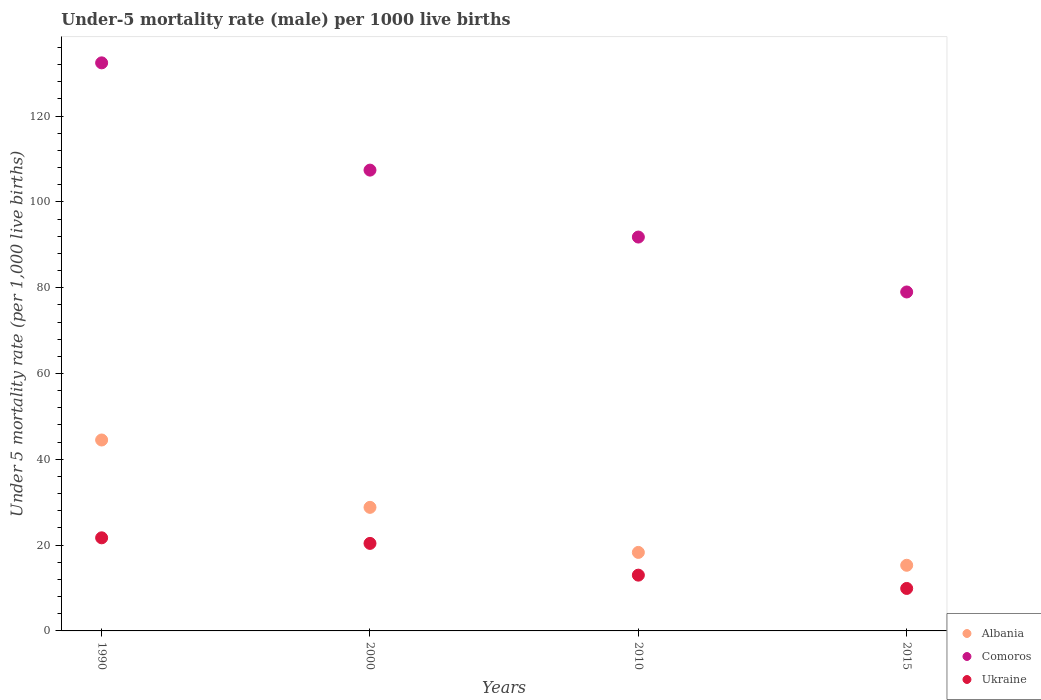What is the under-five mortality rate in Ukraine in 2015?
Make the answer very short. 9.9. Across all years, what is the maximum under-five mortality rate in Ukraine?
Your answer should be compact. 21.7. Across all years, what is the minimum under-five mortality rate in Comoros?
Keep it short and to the point. 79. In which year was the under-five mortality rate in Albania maximum?
Give a very brief answer. 1990. In which year was the under-five mortality rate in Albania minimum?
Offer a very short reply. 2015. What is the total under-five mortality rate in Comoros in the graph?
Make the answer very short. 410.6. What is the difference between the under-five mortality rate in Comoros in 1990 and that in 2000?
Ensure brevity in your answer.  25. What is the difference between the under-five mortality rate in Comoros in 2015 and the under-five mortality rate in Ukraine in 1990?
Give a very brief answer. 57.3. What is the average under-five mortality rate in Ukraine per year?
Your response must be concise. 16.25. In the year 2010, what is the difference between the under-five mortality rate in Ukraine and under-five mortality rate in Albania?
Ensure brevity in your answer.  -5.3. What is the ratio of the under-five mortality rate in Comoros in 2000 to that in 2010?
Give a very brief answer. 1.17. Is the under-five mortality rate in Ukraine in 2000 less than that in 2015?
Your answer should be very brief. No. Is the difference between the under-five mortality rate in Ukraine in 1990 and 2010 greater than the difference between the under-five mortality rate in Albania in 1990 and 2010?
Provide a succinct answer. No. What is the difference between the highest and the second highest under-five mortality rate in Albania?
Your answer should be very brief. 15.7. What is the difference between the highest and the lowest under-five mortality rate in Ukraine?
Your response must be concise. 11.8. In how many years, is the under-five mortality rate in Ukraine greater than the average under-five mortality rate in Ukraine taken over all years?
Your answer should be very brief. 2. Is it the case that in every year, the sum of the under-five mortality rate in Albania and under-five mortality rate in Ukraine  is greater than the under-five mortality rate in Comoros?
Offer a very short reply. No. Is the under-five mortality rate in Comoros strictly greater than the under-five mortality rate in Ukraine over the years?
Your response must be concise. Yes. Is the under-five mortality rate in Ukraine strictly less than the under-five mortality rate in Albania over the years?
Keep it short and to the point. Yes. What is the difference between two consecutive major ticks on the Y-axis?
Your answer should be compact. 20. Does the graph contain grids?
Keep it short and to the point. No. What is the title of the graph?
Provide a short and direct response. Under-5 mortality rate (male) per 1000 live births. What is the label or title of the X-axis?
Offer a very short reply. Years. What is the label or title of the Y-axis?
Give a very brief answer. Under 5 mortality rate (per 1,0 live births). What is the Under 5 mortality rate (per 1,000 live births) in Albania in 1990?
Your answer should be very brief. 44.5. What is the Under 5 mortality rate (per 1,000 live births) in Comoros in 1990?
Make the answer very short. 132.4. What is the Under 5 mortality rate (per 1,000 live births) of Ukraine in 1990?
Give a very brief answer. 21.7. What is the Under 5 mortality rate (per 1,000 live births) of Albania in 2000?
Offer a terse response. 28.8. What is the Under 5 mortality rate (per 1,000 live births) in Comoros in 2000?
Provide a short and direct response. 107.4. What is the Under 5 mortality rate (per 1,000 live births) of Ukraine in 2000?
Make the answer very short. 20.4. What is the Under 5 mortality rate (per 1,000 live births) in Comoros in 2010?
Your response must be concise. 91.8. What is the Under 5 mortality rate (per 1,000 live births) in Ukraine in 2010?
Your response must be concise. 13. What is the Under 5 mortality rate (per 1,000 live births) of Comoros in 2015?
Give a very brief answer. 79. Across all years, what is the maximum Under 5 mortality rate (per 1,000 live births) of Albania?
Ensure brevity in your answer.  44.5. Across all years, what is the maximum Under 5 mortality rate (per 1,000 live births) of Comoros?
Provide a short and direct response. 132.4. Across all years, what is the maximum Under 5 mortality rate (per 1,000 live births) of Ukraine?
Provide a succinct answer. 21.7. Across all years, what is the minimum Under 5 mortality rate (per 1,000 live births) of Albania?
Provide a succinct answer. 15.3. Across all years, what is the minimum Under 5 mortality rate (per 1,000 live births) of Comoros?
Make the answer very short. 79. What is the total Under 5 mortality rate (per 1,000 live births) in Albania in the graph?
Your answer should be compact. 106.9. What is the total Under 5 mortality rate (per 1,000 live births) in Comoros in the graph?
Offer a very short reply. 410.6. What is the difference between the Under 5 mortality rate (per 1,000 live births) in Albania in 1990 and that in 2010?
Your answer should be very brief. 26.2. What is the difference between the Under 5 mortality rate (per 1,000 live births) of Comoros in 1990 and that in 2010?
Keep it short and to the point. 40.6. What is the difference between the Under 5 mortality rate (per 1,000 live births) of Albania in 1990 and that in 2015?
Your answer should be very brief. 29.2. What is the difference between the Under 5 mortality rate (per 1,000 live births) of Comoros in 1990 and that in 2015?
Your answer should be very brief. 53.4. What is the difference between the Under 5 mortality rate (per 1,000 live births) of Albania in 2000 and that in 2010?
Offer a terse response. 10.5. What is the difference between the Under 5 mortality rate (per 1,000 live births) of Comoros in 2000 and that in 2010?
Offer a very short reply. 15.6. What is the difference between the Under 5 mortality rate (per 1,000 live births) of Albania in 2000 and that in 2015?
Your answer should be compact. 13.5. What is the difference between the Under 5 mortality rate (per 1,000 live births) of Comoros in 2000 and that in 2015?
Provide a short and direct response. 28.4. What is the difference between the Under 5 mortality rate (per 1,000 live births) of Albania in 2010 and that in 2015?
Offer a terse response. 3. What is the difference between the Under 5 mortality rate (per 1,000 live births) of Comoros in 2010 and that in 2015?
Offer a very short reply. 12.8. What is the difference between the Under 5 mortality rate (per 1,000 live births) of Albania in 1990 and the Under 5 mortality rate (per 1,000 live births) of Comoros in 2000?
Offer a terse response. -62.9. What is the difference between the Under 5 mortality rate (per 1,000 live births) of Albania in 1990 and the Under 5 mortality rate (per 1,000 live births) of Ukraine in 2000?
Make the answer very short. 24.1. What is the difference between the Under 5 mortality rate (per 1,000 live births) of Comoros in 1990 and the Under 5 mortality rate (per 1,000 live births) of Ukraine in 2000?
Your answer should be compact. 112. What is the difference between the Under 5 mortality rate (per 1,000 live births) in Albania in 1990 and the Under 5 mortality rate (per 1,000 live births) in Comoros in 2010?
Provide a short and direct response. -47.3. What is the difference between the Under 5 mortality rate (per 1,000 live births) in Albania in 1990 and the Under 5 mortality rate (per 1,000 live births) in Ukraine in 2010?
Give a very brief answer. 31.5. What is the difference between the Under 5 mortality rate (per 1,000 live births) in Comoros in 1990 and the Under 5 mortality rate (per 1,000 live births) in Ukraine in 2010?
Ensure brevity in your answer.  119.4. What is the difference between the Under 5 mortality rate (per 1,000 live births) of Albania in 1990 and the Under 5 mortality rate (per 1,000 live births) of Comoros in 2015?
Keep it short and to the point. -34.5. What is the difference between the Under 5 mortality rate (per 1,000 live births) of Albania in 1990 and the Under 5 mortality rate (per 1,000 live births) of Ukraine in 2015?
Provide a succinct answer. 34.6. What is the difference between the Under 5 mortality rate (per 1,000 live births) in Comoros in 1990 and the Under 5 mortality rate (per 1,000 live births) in Ukraine in 2015?
Keep it short and to the point. 122.5. What is the difference between the Under 5 mortality rate (per 1,000 live births) in Albania in 2000 and the Under 5 mortality rate (per 1,000 live births) in Comoros in 2010?
Your response must be concise. -63. What is the difference between the Under 5 mortality rate (per 1,000 live births) of Albania in 2000 and the Under 5 mortality rate (per 1,000 live births) of Ukraine in 2010?
Your response must be concise. 15.8. What is the difference between the Under 5 mortality rate (per 1,000 live births) in Comoros in 2000 and the Under 5 mortality rate (per 1,000 live births) in Ukraine in 2010?
Your answer should be compact. 94.4. What is the difference between the Under 5 mortality rate (per 1,000 live births) in Albania in 2000 and the Under 5 mortality rate (per 1,000 live births) in Comoros in 2015?
Give a very brief answer. -50.2. What is the difference between the Under 5 mortality rate (per 1,000 live births) of Comoros in 2000 and the Under 5 mortality rate (per 1,000 live births) of Ukraine in 2015?
Give a very brief answer. 97.5. What is the difference between the Under 5 mortality rate (per 1,000 live births) of Albania in 2010 and the Under 5 mortality rate (per 1,000 live births) of Comoros in 2015?
Your answer should be very brief. -60.7. What is the difference between the Under 5 mortality rate (per 1,000 live births) of Albania in 2010 and the Under 5 mortality rate (per 1,000 live births) of Ukraine in 2015?
Your answer should be very brief. 8.4. What is the difference between the Under 5 mortality rate (per 1,000 live births) of Comoros in 2010 and the Under 5 mortality rate (per 1,000 live births) of Ukraine in 2015?
Give a very brief answer. 81.9. What is the average Under 5 mortality rate (per 1,000 live births) in Albania per year?
Your answer should be compact. 26.73. What is the average Under 5 mortality rate (per 1,000 live births) of Comoros per year?
Offer a very short reply. 102.65. What is the average Under 5 mortality rate (per 1,000 live births) in Ukraine per year?
Ensure brevity in your answer.  16.25. In the year 1990, what is the difference between the Under 5 mortality rate (per 1,000 live births) in Albania and Under 5 mortality rate (per 1,000 live births) in Comoros?
Provide a short and direct response. -87.9. In the year 1990, what is the difference between the Under 5 mortality rate (per 1,000 live births) in Albania and Under 5 mortality rate (per 1,000 live births) in Ukraine?
Provide a short and direct response. 22.8. In the year 1990, what is the difference between the Under 5 mortality rate (per 1,000 live births) in Comoros and Under 5 mortality rate (per 1,000 live births) in Ukraine?
Your response must be concise. 110.7. In the year 2000, what is the difference between the Under 5 mortality rate (per 1,000 live births) in Albania and Under 5 mortality rate (per 1,000 live births) in Comoros?
Your answer should be very brief. -78.6. In the year 2000, what is the difference between the Under 5 mortality rate (per 1,000 live births) of Albania and Under 5 mortality rate (per 1,000 live births) of Ukraine?
Provide a succinct answer. 8.4. In the year 2010, what is the difference between the Under 5 mortality rate (per 1,000 live births) in Albania and Under 5 mortality rate (per 1,000 live births) in Comoros?
Ensure brevity in your answer.  -73.5. In the year 2010, what is the difference between the Under 5 mortality rate (per 1,000 live births) of Comoros and Under 5 mortality rate (per 1,000 live births) of Ukraine?
Ensure brevity in your answer.  78.8. In the year 2015, what is the difference between the Under 5 mortality rate (per 1,000 live births) in Albania and Under 5 mortality rate (per 1,000 live births) in Comoros?
Your response must be concise. -63.7. In the year 2015, what is the difference between the Under 5 mortality rate (per 1,000 live births) of Comoros and Under 5 mortality rate (per 1,000 live births) of Ukraine?
Provide a short and direct response. 69.1. What is the ratio of the Under 5 mortality rate (per 1,000 live births) in Albania in 1990 to that in 2000?
Keep it short and to the point. 1.55. What is the ratio of the Under 5 mortality rate (per 1,000 live births) of Comoros in 1990 to that in 2000?
Your answer should be very brief. 1.23. What is the ratio of the Under 5 mortality rate (per 1,000 live births) of Ukraine in 1990 to that in 2000?
Provide a succinct answer. 1.06. What is the ratio of the Under 5 mortality rate (per 1,000 live births) of Albania in 1990 to that in 2010?
Keep it short and to the point. 2.43. What is the ratio of the Under 5 mortality rate (per 1,000 live births) of Comoros in 1990 to that in 2010?
Keep it short and to the point. 1.44. What is the ratio of the Under 5 mortality rate (per 1,000 live births) in Ukraine in 1990 to that in 2010?
Ensure brevity in your answer.  1.67. What is the ratio of the Under 5 mortality rate (per 1,000 live births) in Albania in 1990 to that in 2015?
Provide a short and direct response. 2.91. What is the ratio of the Under 5 mortality rate (per 1,000 live births) of Comoros in 1990 to that in 2015?
Offer a terse response. 1.68. What is the ratio of the Under 5 mortality rate (per 1,000 live births) of Ukraine in 1990 to that in 2015?
Your response must be concise. 2.19. What is the ratio of the Under 5 mortality rate (per 1,000 live births) of Albania in 2000 to that in 2010?
Your answer should be very brief. 1.57. What is the ratio of the Under 5 mortality rate (per 1,000 live births) of Comoros in 2000 to that in 2010?
Provide a short and direct response. 1.17. What is the ratio of the Under 5 mortality rate (per 1,000 live births) in Ukraine in 2000 to that in 2010?
Your response must be concise. 1.57. What is the ratio of the Under 5 mortality rate (per 1,000 live births) in Albania in 2000 to that in 2015?
Keep it short and to the point. 1.88. What is the ratio of the Under 5 mortality rate (per 1,000 live births) in Comoros in 2000 to that in 2015?
Provide a succinct answer. 1.36. What is the ratio of the Under 5 mortality rate (per 1,000 live births) in Ukraine in 2000 to that in 2015?
Your answer should be very brief. 2.06. What is the ratio of the Under 5 mortality rate (per 1,000 live births) of Albania in 2010 to that in 2015?
Your answer should be compact. 1.2. What is the ratio of the Under 5 mortality rate (per 1,000 live births) in Comoros in 2010 to that in 2015?
Provide a succinct answer. 1.16. What is the ratio of the Under 5 mortality rate (per 1,000 live births) in Ukraine in 2010 to that in 2015?
Keep it short and to the point. 1.31. What is the difference between the highest and the second highest Under 5 mortality rate (per 1,000 live births) of Ukraine?
Ensure brevity in your answer.  1.3. What is the difference between the highest and the lowest Under 5 mortality rate (per 1,000 live births) in Albania?
Your answer should be very brief. 29.2. What is the difference between the highest and the lowest Under 5 mortality rate (per 1,000 live births) of Comoros?
Make the answer very short. 53.4. What is the difference between the highest and the lowest Under 5 mortality rate (per 1,000 live births) of Ukraine?
Make the answer very short. 11.8. 